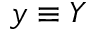Convert formula to latex. <formula><loc_0><loc_0><loc_500><loc_500>y \equiv Y</formula> 